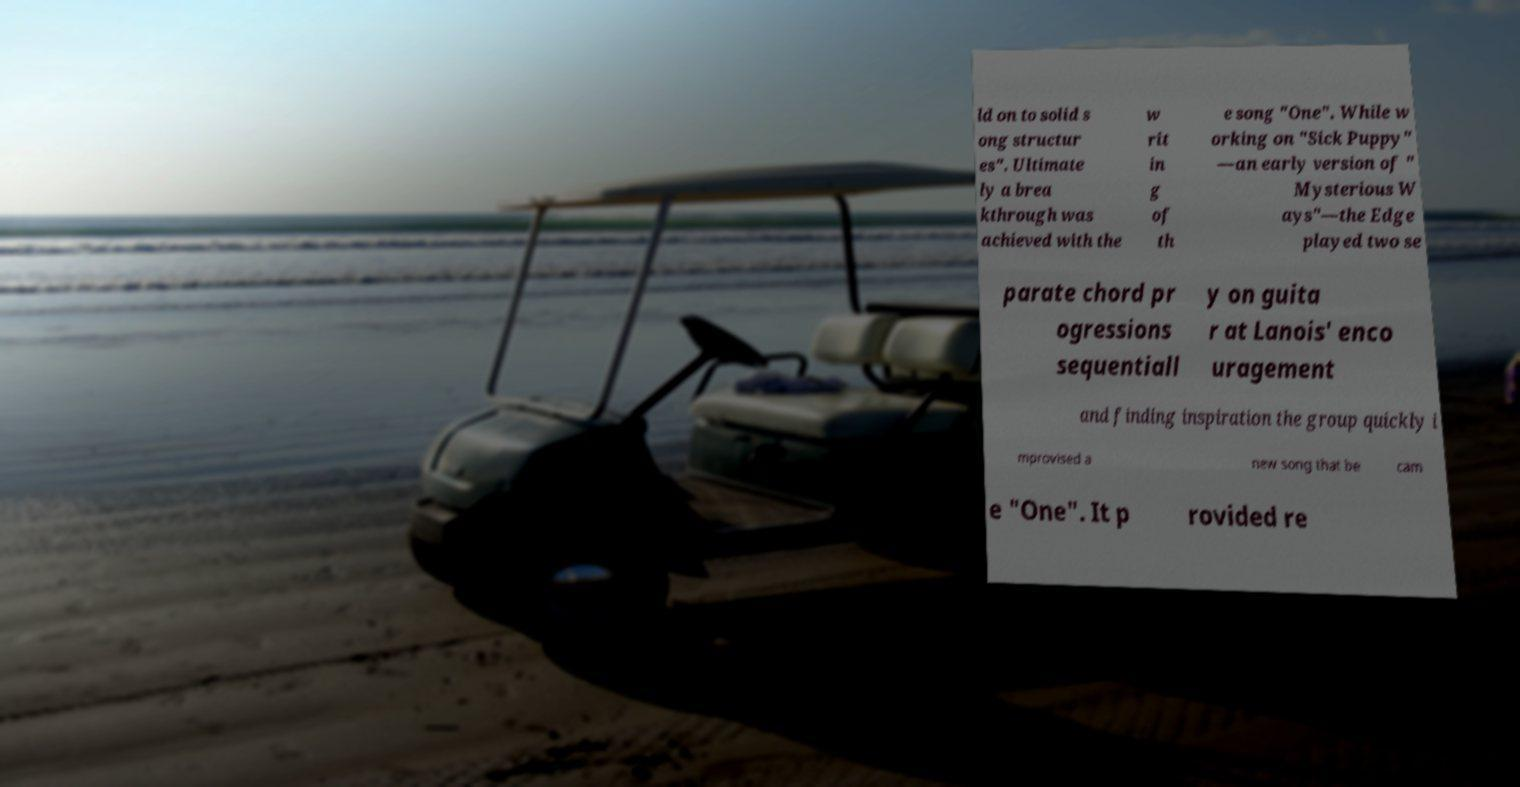I need the written content from this picture converted into text. Can you do that? ld on to solid s ong structur es". Ultimate ly a brea kthrough was achieved with the w rit in g of th e song "One". While w orking on "Sick Puppy" —an early version of " Mysterious W ays"—the Edge played two se parate chord pr ogressions sequentiall y on guita r at Lanois' enco uragement and finding inspiration the group quickly i mprovised a new song that be cam e "One". It p rovided re 